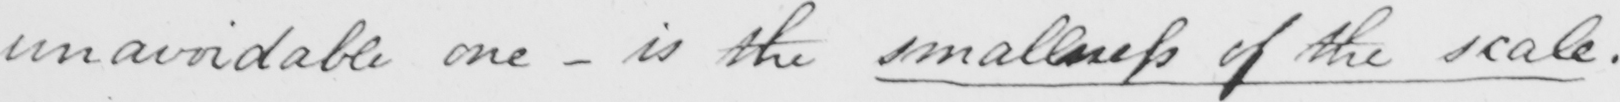Transcribe the text shown in this historical manuscript line. unavoidable one  _  is the smallness of the scale . 